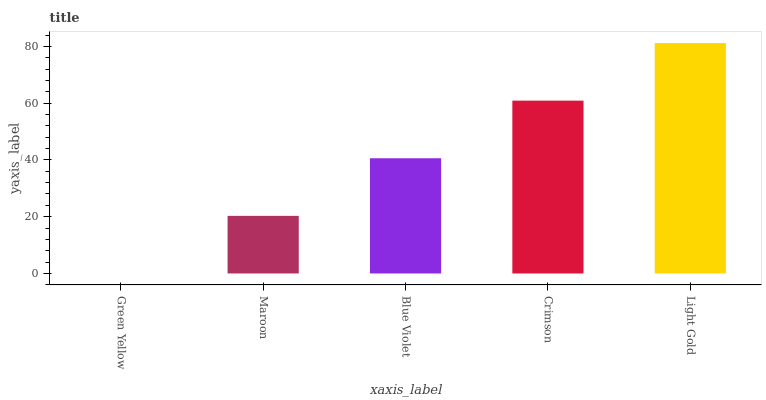Is Green Yellow the minimum?
Answer yes or no. Yes. Is Light Gold the maximum?
Answer yes or no. Yes. Is Maroon the minimum?
Answer yes or no. No. Is Maroon the maximum?
Answer yes or no. No. Is Maroon greater than Green Yellow?
Answer yes or no. Yes. Is Green Yellow less than Maroon?
Answer yes or no. Yes. Is Green Yellow greater than Maroon?
Answer yes or no. No. Is Maroon less than Green Yellow?
Answer yes or no. No. Is Blue Violet the high median?
Answer yes or no. Yes. Is Blue Violet the low median?
Answer yes or no. Yes. Is Maroon the high median?
Answer yes or no. No. Is Green Yellow the low median?
Answer yes or no. No. 